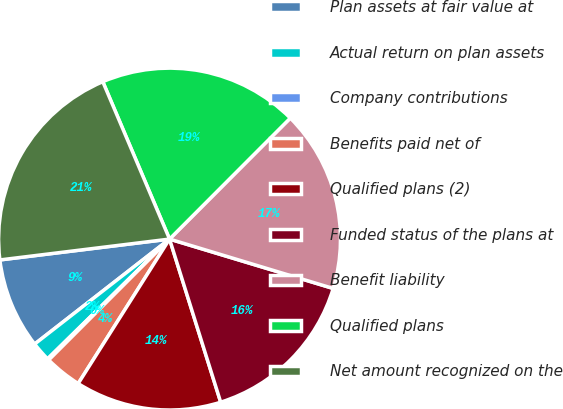Convert chart. <chart><loc_0><loc_0><loc_500><loc_500><pie_chart><fcel>Plan assets at fair value at<fcel>Actual return on plan assets<fcel>Company contributions<fcel>Benefits paid net of<fcel>Qualified plans (2)<fcel>Funded status of the plans at<fcel>Benefit liability<fcel>Qualified plans<fcel>Net amount recognized on the<nl><fcel>8.58%<fcel>1.83%<fcel>0.15%<fcel>3.52%<fcel>13.81%<fcel>15.5%<fcel>17.18%<fcel>18.87%<fcel>20.56%<nl></chart> 